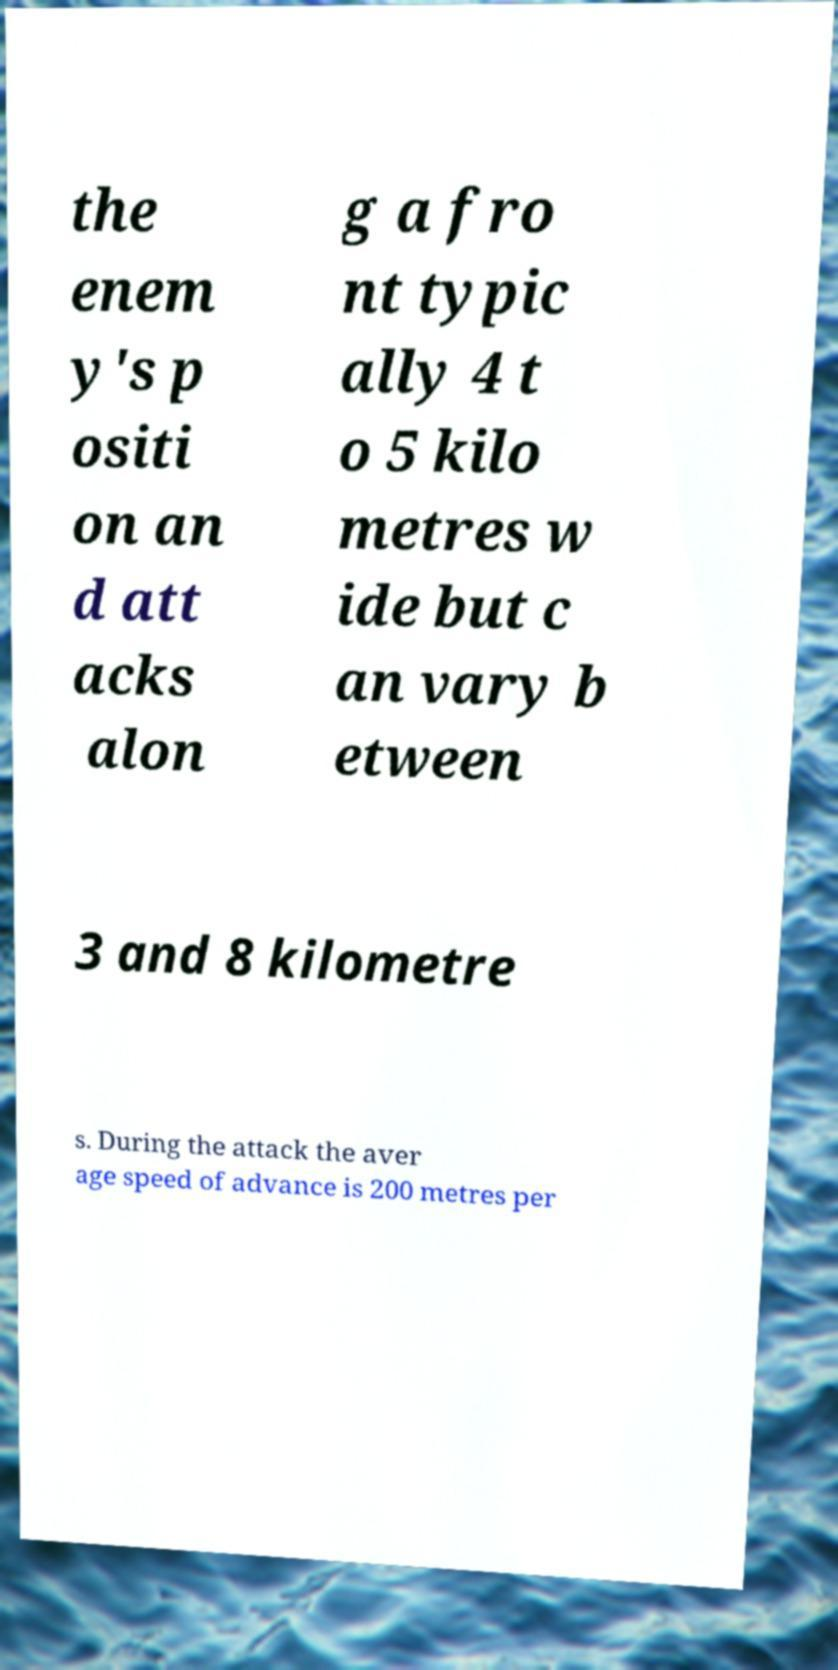I need the written content from this picture converted into text. Can you do that? the enem y's p ositi on an d att acks alon g a fro nt typic ally 4 t o 5 kilo metres w ide but c an vary b etween 3 and 8 kilometre s. During the attack the aver age speed of advance is 200 metres per 